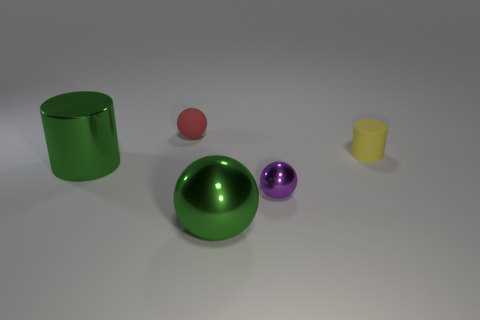What color is the matte cylinder?
Your response must be concise. Yellow. What size is the other object that is the same material as the yellow thing?
Offer a very short reply. Small. How many other matte objects have the same shape as the red rubber object?
Make the answer very short. 0. Is there any other thing that has the same size as the green sphere?
Keep it short and to the point. Yes. How big is the green metal thing to the right of the red thing that is behind the large metallic ball?
Give a very brief answer. Large. What material is the cylinder that is the same size as the matte sphere?
Your answer should be compact. Rubber. Is there another large gray cylinder that has the same material as the big cylinder?
Keep it short and to the point. No. What is the color of the metallic thing in front of the small thing in front of the green metallic thing behind the tiny purple sphere?
Your answer should be compact. Green. There is a cylinder on the left side of the red thing; is it the same color as the small sphere behind the tiny yellow matte cylinder?
Provide a short and direct response. No. Is there any other thing of the same color as the rubber sphere?
Provide a short and direct response. No. 